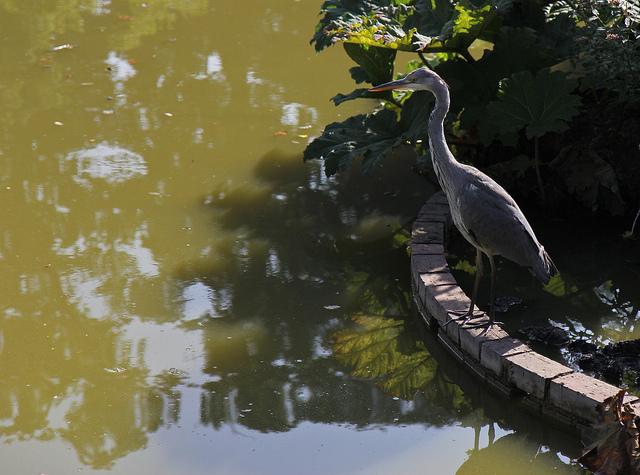What type of animal is shown?
Write a very short answer. Bird. Is the bird going to jump into the water?
Be succinct. No. What color is the water?
Quick response, please. Green. What is cast?
Be succinct. Shadows. 